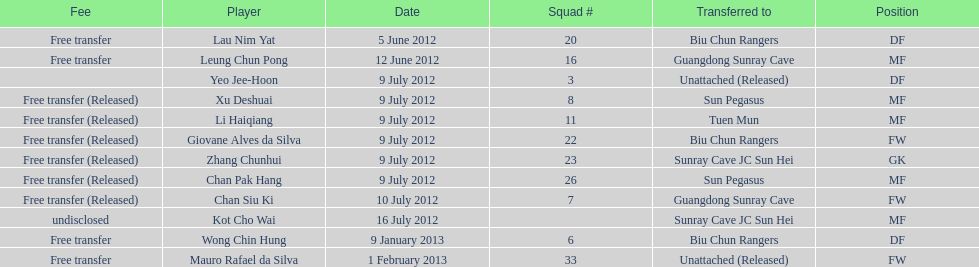Which team did lau nim yat play for after he was transferred? Biu Chun Rangers. 